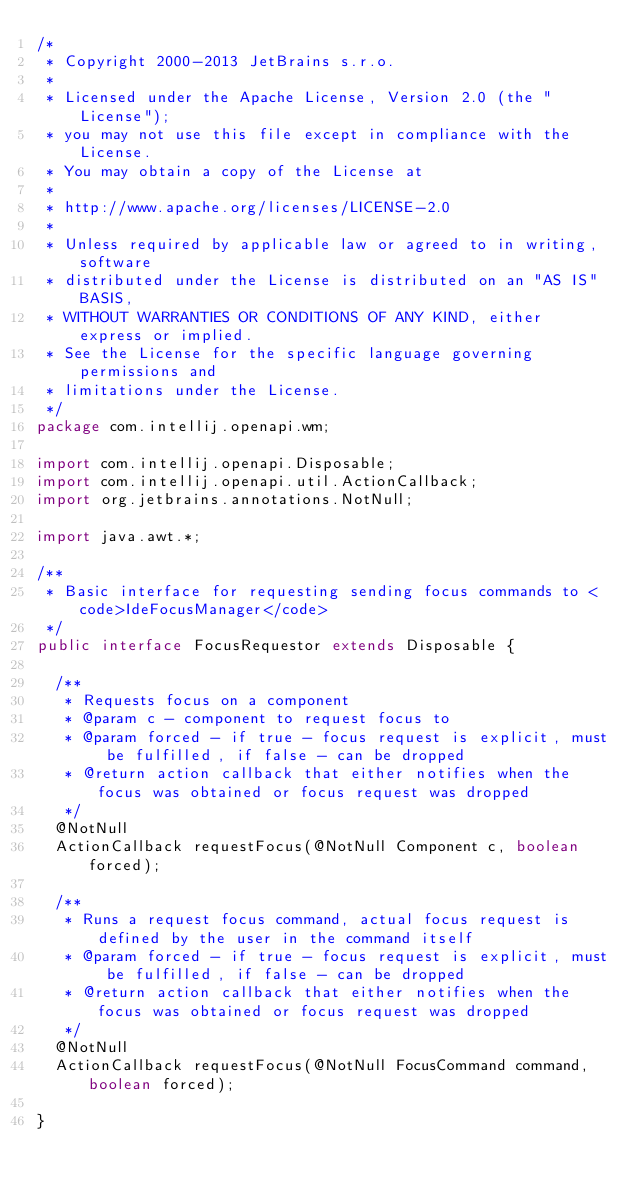<code> <loc_0><loc_0><loc_500><loc_500><_Java_>/*
 * Copyright 2000-2013 JetBrains s.r.o.
 *
 * Licensed under the Apache License, Version 2.0 (the "License");
 * you may not use this file except in compliance with the License.
 * You may obtain a copy of the License at
 *
 * http://www.apache.org/licenses/LICENSE-2.0
 *
 * Unless required by applicable law or agreed to in writing, software
 * distributed under the License is distributed on an "AS IS" BASIS,
 * WITHOUT WARRANTIES OR CONDITIONS OF ANY KIND, either express or implied.
 * See the License for the specific language governing permissions and
 * limitations under the License.
 */
package com.intellij.openapi.wm;

import com.intellij.openapi.Disposable;
import com.intellij.openapi.util.ActionCallback;
import org.jetbrains.annotations.NotNull;

import java.awt.*;

/**
 * Basic interface for requesting sending focus commands to <code>IdeFocusManager</code>
 */
public interface FocusRequestor extends Disposable {

  /**
   * Requests focus on a component
   * @param c - component to request focus to
   * @param forced - if true - focus request is explicit, must be fulfilled, if false - can be dropped
   * @return action callback that either notifies when the focus was obtained or focus request was dropped
   */
  @NotNull
  ActionCallback requestFocus(@NotNull Component c, boolean forced);

  /**
   * Runs a request focus command, actual focus request is defined by the user in the command itself
   * @param forced - if true - focus request is explicit, must be fulfilled, if false - can be dropped
   * @return action callback that either notifies when the focus was obtained or focus request was dropped
   */
  @NotNull
  ActionCallback requestFocus(@NotNull FocusCommand command, boolean forced);
  
}
</code> 